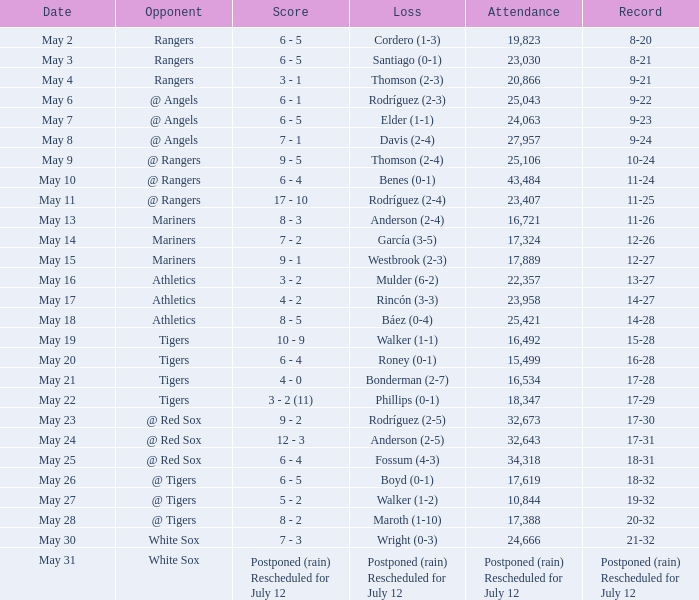What was the specific date when the indians had a 14-28 record? May 18. 